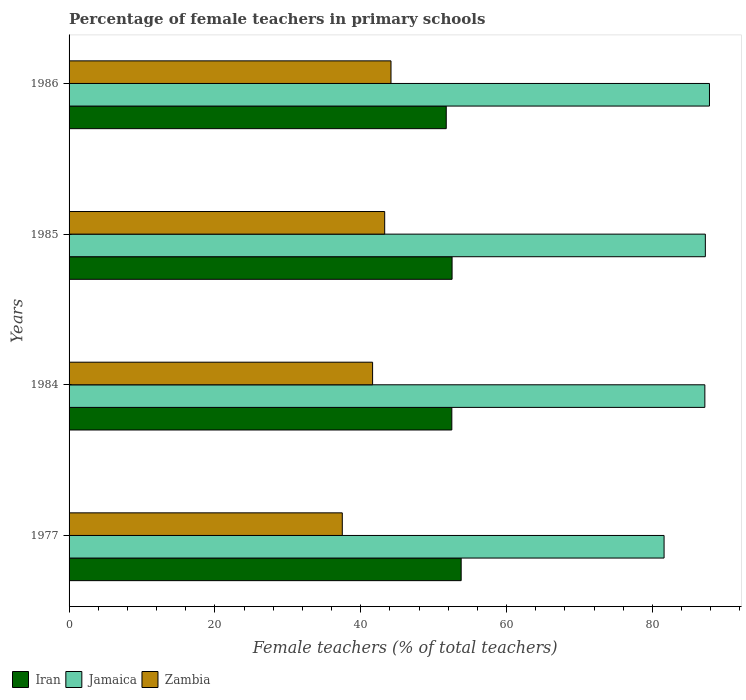How many different coloured bars are there?
Provide a short and direct response. 3. How many groups of bars are there?
Keep it short and to the point. 4. Are the number of bars on each tick of the Y-axis equal?
Keep it short and to the point. Yes. How many bars are there on the 1st tick from the top?
Make the answer very short. 3. How many bars are there on the 3rd tick from the bottom?
Keep it short and to the point. 3. What is the label of the 4th group of bars from the top?
Provide a short and direct response. 1977. What is the percentage of female teachers in Zambia in 1977?
Your response must be concise. 37.47. Across all years, what is the maximum percentage of female teachers in Jamaica?
Your answer should be compact. 87.83. Across all years, what is the minimum percentage of female teachers in Jamaica?
Keep it short and to the point. 81.61. What is the total percentage of female teachers in Iran in the graph?
Provide a succinct answer. 210.53. What is the difference between the percentage of female teachers in Iran in 1984 and that in 1985?
Provide a short and direct response. -0.04. What is the difference between the percentage of female teachers in Iran in 1977 and the percentage of female teachers in Jamaica in 1984?
Your response must be concise. -33.42. What is the average percentage of female teachers in Jamaica per year?
Ensure brevity in your answer.  85.98. In the year 1984, what is the difference between the percentage of female teachers in Iran and percentage of female teachers in Zambia?
Ensure brevity in your answer.  10.87. In how many years, is the percentage of female teachers in Jamaica greater than 56 %?
Your answer should be compact. 4. What is the ratio of the percentage of female teachers in Iran in 1977 to that in 1984?
Give a very brief answer. 1.02. What is the difference between the highest and the second highest percentage of female teachers in Jamaica?
Your answer should be compact. 0.57. What is the difference between the highest and the lowest percentage of female teachers in Jamaica?
Make the answer very short. 6.23. What does the 1st bar from the top in 1984 represents?
Your answer should be compact. Zambia. What does the 3rd bar from the bottom in 1985 represents?
Offer a terse response. Zambia. Is it the case that in every year, the sum of the percentage of female teachers in Iran and percentage of female teachers in Zambia is greater than the percentage of female teachers in Jamaica?
Give a very brief answer. Yes. How many years are there in the graph?
Offer a very short reply. 4. Are the values on the major ticks of X-axis written in scientific E-notation?
Provide a succinct answer. No. Does the graph contain any zero values?
Provide a short and direct response. No. Does the graph contain grids?
Your answer should be compact. No. Where does the legend appear in the graph?
Provide a succinct answer. Bottom left. What is the title of the graph?
Your answer should be very brief. Percentage of female teachers in primary schools. What is the label or title of the X-axis?
Provide a succinct answer. Female teachers (% of total teachers). What is the Female teachers (% of total teachers) of Iran in 1977?
Your answer should be compact. 53.78. What is the Female teachers (% of total teachers) of Jamaica in 1977?
Ensure brevity in your answer.  81.61. What is the Female teachers (% of total teachers) in Zambia in 1977?
Ensure brevity in your answer.  37.47. What is the Female teachers (% of total teachers) of Iran in 1984?
Make the answer very short. 52.49. What is the Female teachers (% of total teachers) in Jamaica in 1984?
Give a very brief answer. 87.2. What is the Female teachers (% of total teachers) of Zambia in 1984?
Your answer should be very brief. 41.63. What is the Female teachers (% of total teachers) in Iran in 1985?
Offer a terse response. 52.53. What is the Female teachers (% of total teachers) of Jamaica in 1985?
Offer a terse response. 87.26. What is the Female teachers (% of total teachers) of Zambia in 1985?
Ensure brevity in your answer.  43.29. What is the Female teachers (% of total teachers) of Iran in 1986?
Keep it short and to the point. 51.73. What is the Female teachers (% of total teachers) in Jamaica in 1986?
Your answer should be compact. 87.83. What is the Female teachers (% of total teachers) in Zambia in 1986?
Give a very brief answer. 44.15. Across all years, what is the maximum Female teachers (% of total teachers) of Iran?
Make the answer very short. 53.78. Across all years, what is the maximum Female teachers (% of total teachers) in Jamaica?
Ensure brevity in your answer.  87.83. Across all years, what is the maximum Female teachers (% of total teachers) of Zambia?
Provide a short and direct response. 44.15. Across all years, what is the minimum Female teachers (% of total teachers) in Iran?
Your response must be concise. 51.73. Across all years, what is the minimum Female teachers (% of total teachers) of Jamaica?
Provide a short and direct response. 81.61. Across all years, what is the minimum Female teachers (% of total teachers) in Zambia?
Ensure brevity in your answer.  37.47. What is the total Female teachers (% of total teachers) of Iran in the graph?
Make the answer very short. 210.53. What is the total Female teachers (% of total teachers) of Jamaica in the graph?
Your answer should be very brief. 343.9. What is the total Female teachers (% of total teachers) of Zambia in the graph?
Provide a succinct answer. 166.54. What is the difference between the Female teachers (% of total teachers) in Iran in 1977 and that in 1984?
Your response must be concise. 1.28. What is the difference between the Female teachers (% of total teachers) in Jamaica in 1977 and that in 1984?
Keep it short and to the point. -5.59. What is the difference between the Female teachers (% of total teachers) in Zambia in 1977 and that in 1984?
Your response must be concise. -4.16. What is the difference between the Female teachers (% of total teachers) of Iran in 1977 and that in 1985?
Offer a terse response. 1.25. What is the difference between the Female teachers (% of total teachers) in Jamaica in 1977 and that in 1985?
Give a very brief answer. -5.66. What is the difference between the Female teachers (% of total teachers) of Zambia in 1977 and that in 1985?
Provide a succinct answer. -5.81. What is the difference between the Female teachers (% of total teachers) in Iran in 1977 and that in 1986?
Provide a short and direct response. 2.05. What is the difference between the Female teachers (% of total teachers) of Jamaica in 1977 and that in 1986?
Your answer should be compact. -6.23. What is the difference between the Female teachers (% of total teachers) of Zambia in 1977 and that in 1986?
Offer a terse response. -6.68. What is the difference between the Female teachers (% of total teachers) of Iran in 1984 and that in 1985?
Your answer should be compact. -0.04. What is the difference between the Female teachers (% of total teachers) of Jamaica in 1984 and that in 1985?
Give a very brief answer. -0.07. What is the difference between the Female teachers (% of total teachers) in Zambia in 1984 and that in 1985?
Give a very brief answer. -1.66. What is the difference between the Female teachers (% of total teachers) in Iran in 1984 and that in 1986?
Offer a terse response. 0.76. What is the difference between the Female teachers (% of total teachers) of Jamaica in 1984 and that in 1986?
Give a very brief answer. -0.63. What is the difference between the Female teachers (% of total teachers) of Zambia in 1984 and that in 1986?
Offer a very short reply. -2.52. What is the difference between the Female teachers (% of total teachers) in Iran in 1985 and that in 1986?
Offer a very short reply. 0.8. What is the difference between the Female teachers (% of total teachers) of Jamaica in 1985 and that in 1986?
Your answer should be very brief. -0.57. What is the difference between the Female teachers (% of total teachers) of Zambia in 1985 and that in 1986?
Make the answer very short. -0.87. What is the difference between the Female teachers (% of total teachers) in Iran in 1977 and the Female teachers (% of total teachers) in Jamaica in 1984?
Ensure brevity in your answer.  -33.42. What is the difference between the Female teachers (% of total teachers) of Iran in 1977 and the Female teachers (% of total teachers) of Zambia in 1984?
Provide a short and direct response. 12.15. What is the difference between the Female teachers (% of total teachers) in Jamaica in 1977 and the Female teachers (% of total teachers) in Zambia in 1984?
Give a very brief answer. 39.98. What is the difference between the Female teachers (% of total teachers) in Iran in 1977 and the Female teachers (% of total teachers) in Jamaica in 1985?
Make the answer very short. -33.49. What is the difference between the Female teachers (% of total teachers) in Iran in 1977 and the Female teachers (% of total teachers) in Zambia in 1985?
Make the answer very short. 10.49. What is the difference between the Female teachers (% of total teachers) in Jamaica in 1977 and the Female teachers (% of total teachers) in Zambia in 1985?
Provide a short and direct response. 38.32. What is the difference between the Female teachers (% of total teachers) in Iran in 1977 and the Female teachers (% of total teachers) in Jamaica in 1986?
Offer a very short reply. -34.05. What is the difference between the Female teachers (% of total teachers) in Iran in 1977 and the Female teachers (% of total teachers) in Zambia in 1986?
Make the answer very short. 9.63. What is the difference between the Female teachers (% of total teachers) in Jamaica in 1977 and the Female teachers (% of total teachers) in Zambia in 1986?
Give a very brief answer. 37.45. What is the difference between the Female teachers (% of total teachers) in Iran in 1984 and the Female teachers (% of total teachers) in Jamaica in 1985?
Offer a terse response. -34.77. What is the difference between the Female teachers (% of total teachers) in Iran in 1984 and the Female teachers (% of total teachers) in Zambia in 1985?
Keep it short and to the point. 9.21. What is the difference between the Female teachers (% of total teachers) of Jamaica in 1984 and the Female teachers (% of total teachers) of Zambia in 1985?
Keep it short and to the point. 43.91. What is the difference between the Female teachers (% of total teachers) in Iran in 1984 and the Female teachers (% of total teachers) in Jamaica in 1986?
Make the answer very short. -35.34. What is the difference between the Female teachers (% of total teachers) in Iran in 1984 and the Female teachers (% of total teachers) in Zambia in 1986?
Your answer should be compact. 8.34. What is the difference between the Female teachers (% of total teachers) in Jamaica in 1984 and the Female teachers (% of total teachers) in Zambia in 1986?
Ensure brevity in your answer.  43.05. What is the difference between the Female teachers (% of total teachers) of Iran in 1985 and the Female teachers (% of total teachers) of Jamaica in 1986?
Provide a short and direct response. -35.3. What is the difference between the Female teachers (% of total teachers) of Iran in 1985 and the Female teachers (% of total teachers) of Zambia in 1986?
Offer a very short reply. 8.38. What is the difference between the Female teachers (% of total teachers) of Jamaica in 1985 and the Female teachers (% of total teachers) of Zambia in 1986?
Your response must be concise. 43.11. What is the average Female teachers (% of total teachers) of Iran per year?
Ensure brevity in your answer.  52.63. What is the average Female teachers (% of total teachers) in Jamaica per year?
Keep it short and to the point. 85.98. What is the average Female teachers (% of total teachers) of Zambia per year?
Offer a terse response. 41.63. In the year 1977, what is the difference between the Female teachers (% of total teachers) in Iran and Female teachers (% of total teachers) in Jamaica?
Your response must be concise. -27.83. In the year 1977, what is the difference between the Female teachers (% of total teachers) of Iran and Female teachers (% of total teachers) of Zambia?
Your answer should be compact. 16.3. In the year 1977, what is the difference between the Female teachers (% of total teachers) in Jamaica and Female teachers (% of total teachers) in Zambia?
Your response must be concise. 44.13. In the year 1984, what is the difference between the Female teachers (% of total teachers) in Iran and Female teachers (% of total teachers) in Jamaica?
Keep it short and to the point. -34.7. In the year 1984, what is the difference between the Female teachers (% of total teachers) of Iran and Female teachers (% of total teachers) of Zambia?
Make the answer very short. 10.87. In the year 1984, what is the difference between the Female teachers (% of total teachers) in Jamaica and Female teachers (% of total teachers) in Zambia?
Provide a short and direct response. 45.57. In the year 1985, what is the difference between the Female teachers (% of total teachers) in Iran and Female teachers (% of total teachers) in Jamaica?
Ensure brevity in your answer.  -34.73. In the year 1985, what is the difference between the Female teachers (% of total teachers) of Iran and Female teachers (% of total teachers) of Zambia?
Offer a very short reply. 9.24. In the year 1985, what is the difference between the Female teachers (% of total teachers) in Jamaica and Female teachers (% of total teachers) in Zambia?
Make the answer very short. 43.98. In the year 1986, what is the difference between the Female teachers (% of total teachers) of Iran and Female teachers (% of total teachers) of Jamaica?
Your answer should be compact. -36.1. In the year 1986, what is the difference between the Female teachers (% of total teachers) of Iran and Female teachers (% of total teachers) of Zambia?
Offer a very short reply. 7.58. In the year 1986, what is the difference between the Female teachers (% of total teachers) of Jamaica and Female teachers (% of total teachers) of Zambia?
Provide a short and direct response. 43.68. What is the ratio of the Female teachers (% of total teachers) in Iran in 1977 to that in 1984?
Ensure brevity in your answer.  1.02. What is the ratio of the Female teachers (% of total teachers) in Jamaica in 1977 to that in 1984?
Your answer should be compact. 0.94. What is the ratio of the Female teachers (% of total teachers) of Zambia in 1977 to that in 1984?
Provide a succinct answer. 0.9. What is the ratio of the Female teachers (% of total teachers) of Iran in 1977 to that in 1985?
Make the answer very short. 1.02. What is the ratio of the Female teachers (% of total teachers) of Jamaica in 1977 to that in 1985?
Offer a very short reply. 0.94. What is the ratio of the Female teachers (% of total teachers) in Zambia in 1977 to that in 1985?
Your answer should be compact. 0.87. What is the ratio of the Female teachers (% of total teachers) in Iran in 1977 to that in 1986?
Provide a short and direct response. 1.04. What is the ratio of the Female teachers (% of total teachers) in Jamaica in 1977 to that in 1986?
Your response must be concise. 0.93. What is the ratio of the Female teachers (% of total teachers) of Zambia in 1977 to that in 1986?
Your response must be concise. 0.85. What is the ratio of the Female teachers (% of total teachers) in Iran in 1984 to that in 1985?
Keep it short and to the point. 1. What is the ratio of the Female teachers (% of total teachers) in Zambia in 1984 to that in 1985?
Offer a very short reply. 0.96. What is the ratio of the Female teachers (% of total teachers) in Iran in 1984 to that in 1986?
Offer a very short reply. 1.01. What is the ratio of the Female teachers (% of total teachers) in Jamaica in 1984 to that in 1986?
Give a very brief answer. 0.99. What is the ratio of the Female teachers (% of total teachers) in Zambia in 1984 to that in 1986?
Provide a short and direct response. 0.94. What is the ratio of the Female teachers (% of total teachers) of Iran in 1985 to that in 1986?
Keep it short and to the point. 1.02. What is the ratio of the Female teachers (% of total teachers) of Jamaica in 1985 to that in 1986?
Your answer should be very brief. 0.99. What is the ratio of the Female teachers (% of total teachers) of Zambia in 1985 to that in 1986?
Your answer should be compact. 0.98. What is the difference between the highest and the second highest Female teachers (% of total teachers) of Iran?
Your answer should be compact. 1.25. What is the difference between the highest and the second highest Female teachers (% of total teachers) of Jamaica?
Ensure brevity in your answer.  0.57. What is the difference between the highest and the second highest Female teachers (% of total teachers) in Zambia?
Provide a short and direct response. 0.87. What is the difference between the highest and the lowest Female teachers (% of total teachers) of Iran?
Your answer should be very brief. 2.05. What is the difference between the highest and the lowest Female teachers (% of total teachers) of Jamaica?
Keep it short and to the point. 6.23. What is the difference between the highest and the lowest Female teachers (% of total teachers) of Zambia?
Your response must be concise. 6.68. 